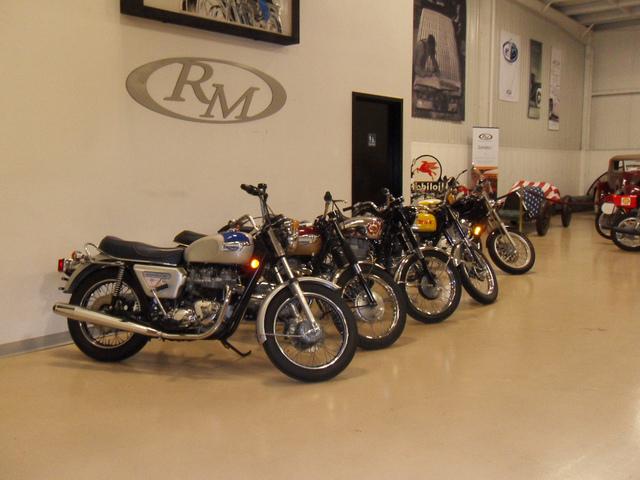How many bikes are seen?
Be succinct. 5. What kind of motorcycle is this?
Write a very short answer. Rm. Is this in the city?
Keep it brief. Yes. What color is the sign on the pole?
Keep it brief. White. Indoor or outdoor?
Answer briefly. Indoor. What color is the sign?
Short answer required. Gray. Is the bike parked outside of a brick building?
Quick response, please. No. How many motorbikes?
Concise answer only. 7. What surface do they stand atop?
Short answer required. Cement. Is there a helmet on every bike?
Answer briefly. No. How many people have bikes?
Answer briefly. 0. Are there people in the photo?
Give a very brief answer. No. What brand of bike do these men have?
Give a very brief answer. Rm. How many bikes are there?
Answer briefly. 7. Is it daytime?
Keep it brief. No. What type of floor is this?
Keep it brief. Concrete. How many bikes are in the photo?
Be succinct. 7. How many motorcycles are in the photo?
Write a very short answer. 6. Is the motorcycle parked on the street?
Quick response, please. No. How many motorcycles are there?
Concise answer only. 5. Are all of the tires facing the same way?
Answer briefly. Yes. Is there more than one bike?
Give a very brief answer. Yes. What color are the bikes?
Give a very brief answer. Black. What color is the ground the motorcycles are sitting on?
Short answer required. Tan. Where is the bike?
Concise answer only. Garage. 